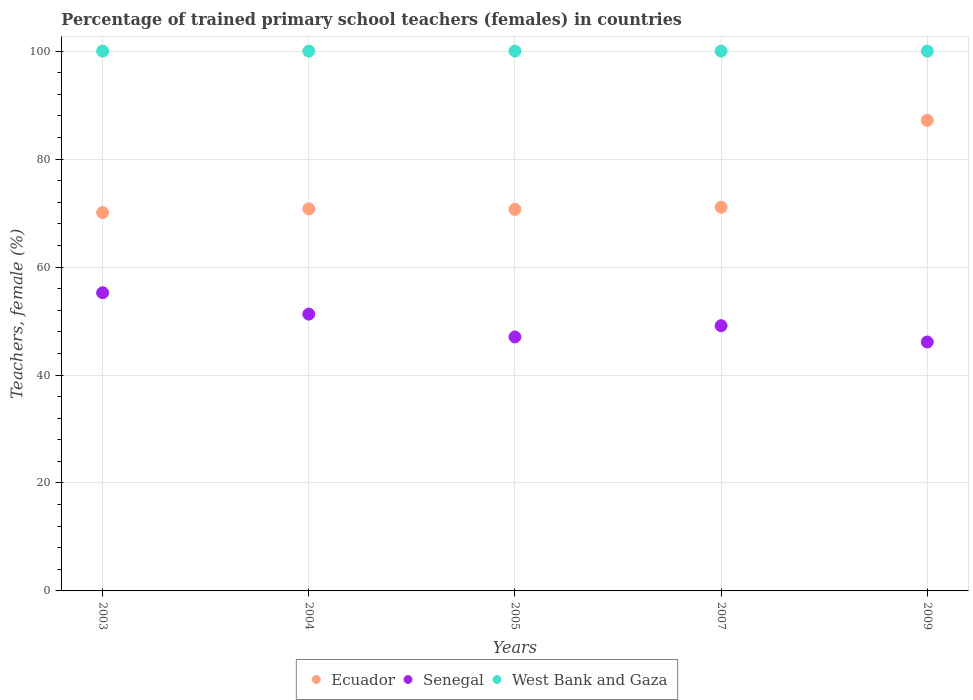How many different coloured dotlines are there?
Your answer should be compact. 3. Is the number of dotlines equal to the number of legend labels?
Make the answer very short. Yes. What is the percentage of trained primary school teachers (females) in Ecuador in 2007?
Offer a very short reply. 71.07. Across all years, what is the maximum percentage of trained primary school teachers (females) in Ecuador?
Offer a terse response. 87.18. Across all years, what is the minimum percentage of trained primary school teachers (females) in Senegal?
Your response must be concise. 46.11. In which year was the percentage of trained primary school teachers (females) in Ecuador maximum?
Keep it short and to the point. 2009. In which year was the percentage of trained primary school teachers (females) in Senegal minimum?
Your answer should be very brief. 2009. What is the total percentage of trained primary school teachers (females) in Ecuador in the graph?
Provide a short and direct response. 369.81. What is the difference between the percentage of trained primary school teachers (females) in West Bank and Gaza in 2004 and that in 2009?
Ensure brevity in your answer.  0. What is the difference between the percentage of trained primary school teachers (females) in West Bank and Gaza in 2007 and the percentage of trained primary school teachers (females) in Senegal in 2009?
Offer a very short reply. 53.89. What is the average percentage of trained primary school teachers (females) in Senegal per year?
Ensure brevity in your answer.  49.76. In the year 2003, what is the difference between the percentage of trained primary school teachers (females) in Ecuador and percentage of trained primary school teachers (females) in Senegal?
Make the answer very short. 14.85. In how many years, is the percentage of trained primary school teachers (females) in Ecuador greater than 44 %?
Offer a terse response. 5. Is the percentage of trained primary school teachers (females) in Ecuador in 2003 less than that in 2005?
Your answer should be very brief. Yes. Is the difference between the percentage of trained primary school teachers (females) in Ecuador in 2004 and 2005 greater than the difference between the percentage of trained primary school teachers (females) in Senegal in 2004 and 2005?
Your response must be concise. No. In how many years, is the percentage of trained primary school teachers (females) in Ecuador greater than the average percentage of trained primary school teachers (females) in Ecuador taken over all years?
Offer a very short reply. 1. Does the percentage of trained primary school teachers (females) in Senegal monotonically increase over the years?
Offer a very short reply. No. Is the percentage of trained primary school teachers (females) in Senegal strictly greater than the percentage of trained primary school teachers (females) in West Bank and Gaza over the years?
Keep it short and to the point. No. Is the percentage of trained primary school teachers (females) in West Bank and Gaza strictly less than the percentage of trained primary school teachers (females) in Ecuador over the years?
Your response must be concise. No. How many dotlines are there?
Provide a short and direct response. 3. How many years are there in the graph?
Provide a short and direct response. 5. What is the difference between two consecutive major ticks on the Y-axis?
Offer a very short reply. 20. Does the graph contain grids?
Offer a very short reply. Yes. Where does the legend appear in the graph?
Keep it short and to the point. Bottom center. How many legend labels are there?
Your answer should be very brief. 3. What is the title of the graph?
Your answer should be very brief. Percentage of trained primary school teachers (females) in countries. Does "Belize" appear as one of the legend labels in the graph?
Give a very brief answer. No. What is the label or title of the X-axis?
Offer a terse response. Years. What is the label or title of the Y-axis?
Your answer should be compact. Teachers, female (%). What is the Teachers, female (%) in Ecuador in 2003?
Ensure brevity in your answer.  70.08. What is the Teachers, female (%) of Senegal in 2003?
Provide a succinct answer. 55.24. What is the Teachers, female (%) of Ecuador in 2004?
Offer a very short reply. 70.78. What is the Teachers, female (%) of Senegal in 2004?
Make the answer very short. 51.28. What is the Teachers, female (%) of Ecuador in 2005?
Your answer should be compact. 70.69. What is the Teachers, female (%) of Senegal in 2005?
Keep it short and to the point. 47.05. What is the Teachers, female (%) of West Bank and Gaza in 2005?
Provide a succinct answer. 100. What is the Teachers, female (%) of Ecuador in 2007?
Your response must be concise. 71.07. What is the Teachers, female (%) of Senegal in 2007?
Make the answer very short. 49.13. What is the Teachers, female (%) in Ecuador in 2009?
Give a very brief answer. 87.18. What is the Teachers, female (%) in Senegal in 2009?
Provide a short and direct response. 46.11. Across all years, what is the maximum Teachers, female (%) in Ecuador?
Offer a very short reply. 87.18. Across all years, what is the maximum Teachers, female (%) in Senegal?
Offer a terse response. 55.24. Across all years, what is the minimum Teachers, female (%) of Ecuador?
Make the answer very short. 70.08. Across all years, what is the minimum Teachers, female (%) in Senegal?
Your answer should be compact. 46.11. Across all years, what is the minimum Teachers, female (%) in West Bank and Gaza?
Make the answer very short. 100. What is the total Teachers, female (%) of Ecuador in the graph?
Offer a very short reply. 369.81. What is the total Teachers, female (%) of Senegal in the graph?
Ensure brevity in your answer.  248.81. What is the difference between the Teachers, female (%) in Ecuador in 2003 and that in 2004?
Give a very brief answer. -0.7. What is the difference between the Teachers, female (%) in Senegal in 2003 and that in 2004?
Provide a short and direct response. 3.96. What is the difference between the Teachers, female (%) of Ecuador in 2003 and that in 2005?
Provide a succinct answer. -0.6. What is the difference between the Teachers, female (%) of Senegal in 2003 and that in 2005?
Give a very brief answer. 8.19. What is the difference between the Teachers, female (%) in West Bank and Gaza in 2003 and that in 2005?
Your response must be concise. 0. What is the difference between the Teachers, female (%) of Ecuador in 2003 and that in 2007?
Provide a succinct answer. -0.99. What is the difference between the Teachers, female (%) of Senegal in 2003 and that in 2007?
Ensure brevity in your answer.  6.1. What is the difference between the Teachers, female (%) of West Bank and Gaza in 2003 and that in 2007?
Ensure brevity in your answer.  0. What is the difference between the Teachers, female (%) of Ecuador in 2003 and that in 2009?
Your answer should be very brief. -17.1. What is the difference between the Teachers, female (%) of Senegal in 2003 and that in 2009?
Your answer should be compact. 9.12. What is the difference between the Teachers, female (%) of West Bank and Gaza in 2003 and that in 2009?
Provide a short and direct response. 0. What is the difference between the Teachers, female (%) of Ecuador in 2004 and that in 2005?
Your response must be concise. 0.1. What is the difference between the Teachers, female (%) in Senegal in 2004 and that in 2005?
Provide a succinct answer. 4.23. What is the difference between the Teachers, female (%) of Ecuador in 2004 and that in 2007?
Provide a succinct answer. -0.29. What is the difference between the Teachers, female (%) of Senegal in 2004 and that in 2007?
Give a very brief answer. 2.14. What is the difference between the Teachers, female (%) of Ecuador in 2004 and that in 2009?
Provide a succinct answer. -16.4. What is the difference between the Teachers, female (%) in Senegal in 2004 and that in 2009?
Your response must be concise. 5.16. What is the difference between the Teachers, female (%) of West Bank and Gaza in 2004 and that in 2009?
Your response must be concise. 0. What is the difference between the Teachers, female (%) in Ecuador in 2005 and that in 2007?
Offer a terse response. -0.39. What is the difference between the Teachers, female (%) in Senegal in 2005 and that in 2007?
Provide a succinct answer. -2.08. What is the difference between the Teachers, female (%) in Ecuador in 2005 and that in 2009?
Your answer should be very brief. -16.49. What is the difference between the Teachers, female (%) of Senegal in 2005 and that in 2009?
Keep it short and to the point. 0.93. What is the difference between the Teachers, female (%) of West Bank and Gaza in 2005 and that in 2009?
Provide a succinct answer. 0. What is the difference between the Teachers, female (%) of Ecuador in 2007 and that in 2009?
Your response must be concise. -16.11. What is the difference between the Teachers, female (%) of Senegal in 2007 and that in 2009?
Keep it short and to the point. 3.02. What is the difference between the Teachers, female (%) of West Bank and Gaza in 2007 and that in 2009?
Your answer should be very brief. 0. What is the difference between the Teachers, female (%) in Ecuador in 2003 and the Teachers, female (%) in Senegal in 2004?
Keep it short and to the point. 18.81. What is the difference between the Teachers, female (%) in Ecuador in 2003 and the Teachers, female (%) in West Bank and Gaza in 2004?
Offer a very short reply. -29.92. What is the difference between the Teachers, female (%) of Senegal in 2003 and the Teachers, female (%) of West Bank and Gaza in 2004?
Provide a short and direct response. -44.76. What is the difference between the Teachers, female (%) in Ecuador in 2003 and the Teachers, female (%) in Senegal in 2005?
Your response must be concise. 23.04. What is the difference between the Teachers, female (%) of Ecuador in 2003 and the Teachers, female (%) of West Bank and Gaza in 2005?
Your answer should be very brief. -29.92. What is the difference between the Teachers, female (%) in Senegal in 2003 and the Teachers, female (%) in West Bank and Gaza in 2005?
Offer a terse response. -44.76. What is the difference between the Teachers, female (%) in Ecuador in 2003 and the Teachers, female (%) in Senegal in 2007?
Keep it short and to the point. 20.95. What is the difference between the Teachers, female (%) in Ecuador in 2003 and the Teachers, female (%) in West Bank and Gaza in 2007?
Offer a terse response. -29.92. What is the difference between the Teachers, female (%) of Senegal in 2003 and the Teachers, female (%) of West Bank and Gaza in 2007?
Make the answer very short. -44.76. What is the difference between the Teachers, female (%) of Ecuador in 2003 and the Teachers, female (%) of Senegal in 2009?
Your answer should be very brief. 23.97. What is the difference between the Teachers, female (%) of Ecuador in 2003 and the Teachers, female (%) of West Bank and Gaza in 2009?
Provide a short and direct response. -29.92. What is the difference between the Teachers, female (%) in Senegal in 2003 and the Teachers, female (%) in West Bank and Gaza in 2009?
Your answer should be compact. -44.76. What is the difference between the Teachers, female (%) in Ecuador in 2004 and the Teachers, female (%) in Senegal in 2005?
Give a very brief answer. 23.73. What is the difference between the Teachers, female (%) of Ecuador in 2004 and the Teachers, female (%) of West Bank and Gaza in 2005?
Keep it short and to the point. -29.22. What is the difference between the Teachers, female (%) of Senegal in 2004 and the Teachers, female (%) of West Bank and Gaza in 2005?
Offer a terse response. -48.72. What is the difference between the Teachers, female (%) in Ecuador in 2004 and the Teachers, female (%) in Senegal in 2007?
Provide a succinct answer. 21.65. What is the difference between the Teachers, female (%) in Ecuador in 2004 and the Teachers, female (%) in West Bank and Gaza in 2007?
Make the answer very short. -29.22. What is the difference between the Teachers, female (%) in Senegal in 2004 and the Teachers, female (%) in West Bank and Gaza in 2007?
Offer a terse response. -48.72. What is the difference between the Teachers, female (%) of Ecuador in 2004 and the Teachers, female (%) of Senegal in 2009?
Make the answer very short. 24.67. What is the difference between the Teachers, female (%) in Ecuador in 2004 and the Teachers, female (%) in West Bank and Gaza in 2009?
Offer a very short reply. -29.22. What is the difference between the Teachers, female (%) of Senegal in 2004 and the Teachers, female (%) of West Bank and Gaza in 2009?
Keep it short and to the point. -48.72. What is the difference between the Teachers, female (%) of Ecuador in 2005 and the Teachers, female (%) of Senegal in 2007?
Make the answer very short. 21.55. What is the difference between the Teachers, female (%) of Ecuador in 2005 and the Teachers, female (%) of West Bank and Gaza in 2007?
Your answer should be very brief. -29.31. What is the difference between the Teachers, female (%) in Senegal in 2005 and the Teachers, female (%) in West Bank and Gaza in 2007?
Offer a very short reply. -52.95. What is the difference between the Teachers, female (%) in Ecuador in 2005 and the Teachers, female (%) in Senegal in 2009?
Your answer should be very brief. 24.57. What is the difference between the Teachers, female (%) in Ecuador in 2005 and the Teachers, female (%) in West Bank and Gaza in 2009?
Give a very brief answer. -29.31. What is the difference between the Teachers, female (%) in Senegal in 2005 and the Teachers, female (%) in West Bank and Gaza in 2009?
Your answer should be compact. -52.95. What is the difference between the Teachers, female (%) of Ecuador in 2007 and the Teachers, female (%) of Senegal in 2009?
Your answer should be very brief. 24.96. What is the difference between the Teachers, female (%) of Ecuador in 2007 and the Teachers, female (%) of West Bank and Gaza in 2009?
Your answer should be compact. -28.93. What is the difference between the Teachers, female (%) of Senegal in 2007 and the Teachers, female (%) of West Bank and Gaza in 2009?
Ensure brevity in your answer.  -50.87. What is the average Teachers, female (%) of Ecuador per year?
Provide a short and direct response. 73.96. What is the average Teachers, female (%) of Senegal per year?
Provide a succinct answer. 49.76. What is the average Teachers, female (%) of West Bank and Gaza per year?
Provide a succinct answer. 100. In the year 2003, what is the difference between the Teachers, female (%) in Ecuador and Teachers, female (%) in Senegal?
Give a very brief answer. 14.85. In the year 2003, what is the difference between the Teachers, female (%) of Ecuador and Teachers, female (%) of West Bank and Gaza?
Keep it short and to the point. -29.92. In the year 2003, what is the difference between the Teachers, female (%) in Senegal and Teachers, female (%) in West Bank and Gaza?
Your answer should be compact. -44.76. In the year 2004, what is the difference between the Teachers, female (%) of Ecuador and Teachers, female (%) of Senegal?
Make the answer very short. 19.51. In the year 2004, what is the difference between the Teachers, female (%) in Ecuador and Teachers, female (%) in West Bank and Gaza?
Your answer should be compact. -29.22. In the year 2004, what is the difference between the Teachers, female (%) of Senegal and Teachers, female (%) of West Bank and Gaza?
Offer a very short reply. -48.72. In the year 2005, what is the difference between the Teachers, female (%) in Ecuador and Teachers, female (%) in Senegal?
Your answer should be compact. 23.64. In the year 2005, what is the difference between the Teachers, female (%) in Ecuador and Teachers, female (%) in West Bank and Gaza?
Provide a succinct answer. -29.31. In the year 2005, what is the difference between the Teachers, female (%) in Senegal and Teachers, female (%) in West Bank and Gaza?
Your answer should be very brief. -52.95. In the year 2007, what is the difference between the Teachers, female (%) of Ecuador and Teachers, female (%) of Senegal?
Provide a succinct answer. 21.94. In the year 2007, what is the difference between the Teachers, female (%) of Ecuador and Teachers, female (%) of West Bank and Gaza?
Your answer should be compact. -28.93. In the year 2007, what is the difference between the Teachers, female (%) in Senegal and Teachers, female (%) in West Bank and Gaza?
Your answer should be compact. -50.87. In the year 2009, what is the difference between the Teachers, female (%) of Ecuador and Teachers, female (%) of Senegal?
Make the answer very short. 41.07. In the year 2009, what is the difference between the Teachers, female (%) of Ecuador and Teachers, female (%) of West Bank and Gaza?
Keep it short and to the point. -12.82. In the year 2009, what is the difference between the Teachers, female (%) in Senegal and Teachers, female (%) in West Bank and Gaza?
Offer a very short reply. -53.89. What is the ratio of the Teachers, female (%) of Ecuador in 2003 to that in 2004?
Give a very brief answer. 0.99. What is the ratio of the Teachers, female (%) of Senegal in 2003 to that in 2004?
Your answer should be very brief. 1.08. What is the ratio of the Teachers, female (%) in Ecuador in 2003 to that in 2005?
Ensure brevity in your answer.  0.99. What is the ratio of the Teachers, female (%) of Senegal in 2003 to that in 2005?
Give a very brief answer. 1.17. What is the ratio of the Teachers, female (%) of West Bank and Gaza in 2003 to that in 2005?
Keep it short and to the point. 1. What is the ratio of the Teachers, female (%) in Ecuador in 2003 to that in 2007?
Offer a terse response. 0.99. What is the ratio of the Teachers, female (%) of Senegal in 2003 to that in 2007?
Offer a very short reply. 1.12. What is the ratio of the Teachers, female (%) of Ecuador in 2003 to that in 2009?
Provide a succinct answer. 0.8. What is the ratio of the Teachers, female (%) of Senegal in 2003 to that in 2009?
Offer a very short reply. 1.2. What is the ratio of the Teachers, female (%) in West Bank and Gaza in 2003 to that in 2009?
Keep it short and to the point. 1. What is the ratio of the Teachers, female (%) of Ecuador in 2004 to that in 2005?
Your answer should be compact. 1. What is the ratio of the Teachers, female (%) of Senegal in 2004 to that in 2005?
Provide a succinct answer. 1.09. What is the ratio of the Teachers, female (%) of West Bank and Gaza in 2004 to that in 2005?
Your answer should be very brief. 1. What is the ratio of the Teachers, female (%) of Senegal in 2004 to that in 2007?
Your response must be concise. 1.04. What is the ratio of the Teachers, female (%) in West Bank and Gaza in 2004 to that in 2007?
Ensure brevity in your answer.  1. What is the ratio of the Teachers, female (%) of Ecuador in 2004 to that in 2009?
Your answer should be compact. 0.81. What is the ratio of the Teachers, female (%) of Senegal in 2004 to that in 2009?
Ensure brevity in your answer.  1.11. What is the ratio of the Teachers, female (%) of West Bank and Gaza in 2004 to that in 2009?
Provide a succinct answer. 1. What is the ratio of the Teachers, female (%) in Ecuador in 2005 to that in 2007?
Provide a succinct answer. 0.99. What is the ratio of the Teachers, female (%) in Senegal in 2005 to that in 2007?
Your answer should be very brief. 0.96. What is the ratio of the Teachers, female (%) of West Bank and Gaza in 2005 to that in 2007?
Your answer should be compact. 1. What is the ratio of the Teachers, female (%) of Ecuador in 2005 to that in 2009?
Keep it short and to the point. 0.81. What is the ratio of the Teachers, female (%) in Senegal in 2005 to that in 2009?
Your response must be concise. 1.02. What is the ratio of the Teachers, female (%) of Ecuador in 2007 to that in 2009?
Offer a very short reply. 0.82. What is the ratio of the Teachers, female (%) in Senegal in 2007 to that in 2009?
Provide a succinct answer. 1.07. What is the difference between the highest and the second highest Teachers, female (%) of Ecuador?
Provide a succinct answer. 16.11. What is the difference between the highest and the second highest Teachers, female (%) in Senegal?
Offer a terse response. 3.96. What is the difference between the highest and the second highest Teachers, female (%) in West Bank and Gaza?
Give a very brief answer. 0. What is the difference between the highest and the lowest Teachers, female (%) in Ecuador?
Ensure brevity in your answer.  17.1. What is the difference between the highest and the lowest Teachers, female (%) in Senegal?
Offer a very short reply. 9.12. What is the difference between the highest and the lowest Teachers, female (%) in West Bank and Gaza?
Your response must be concise. 0. 